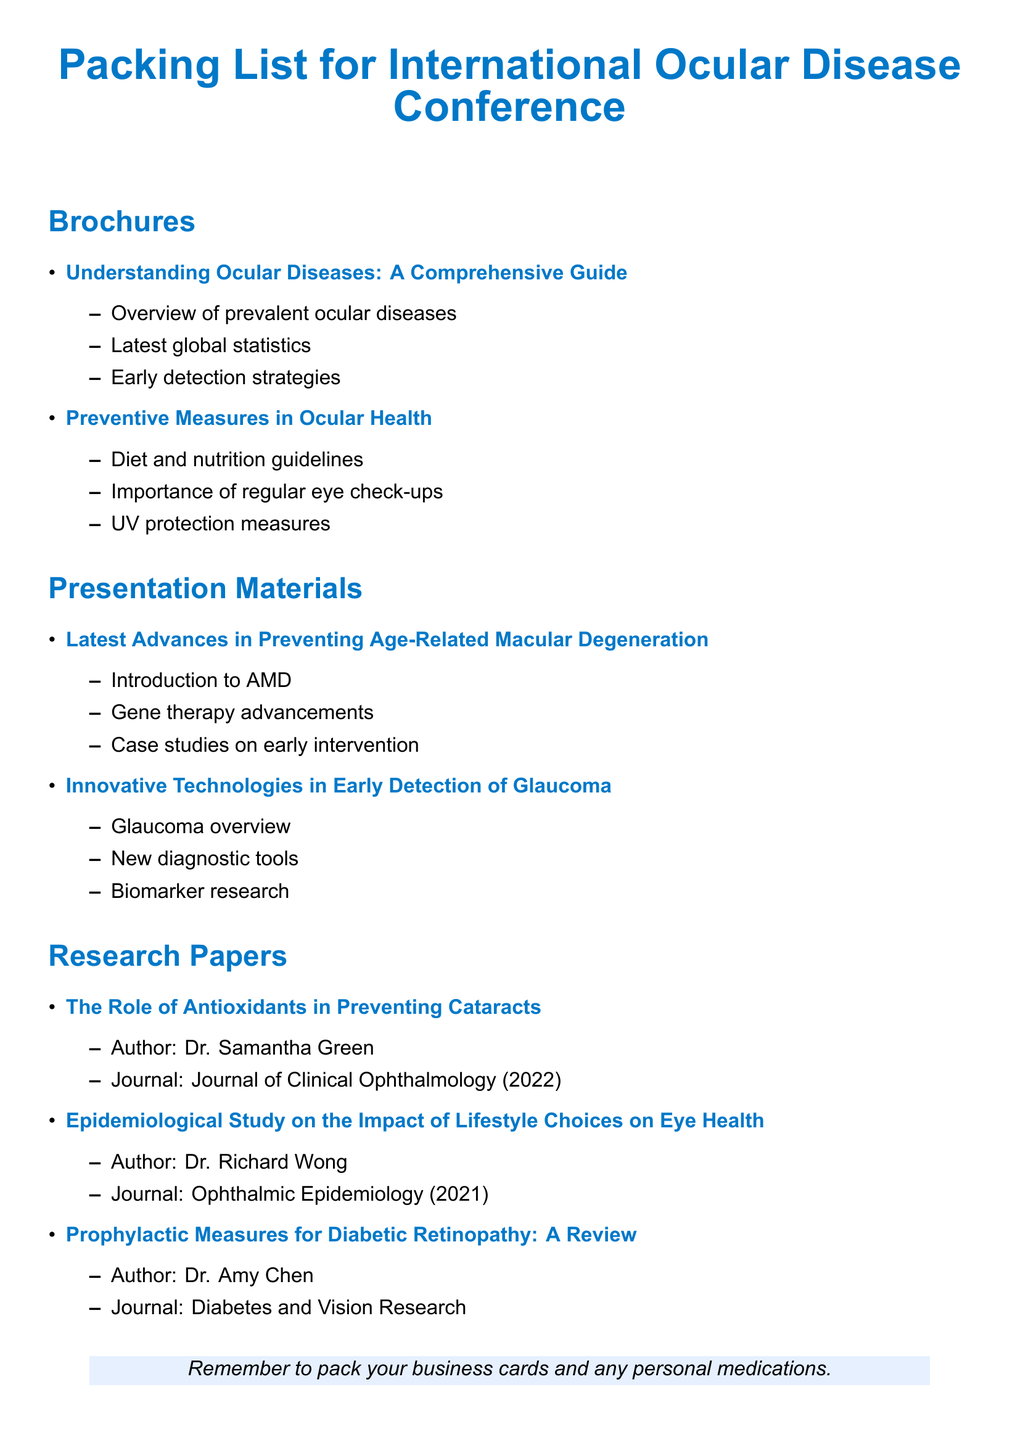What is the title of the brochure that discusses diet and nutrition? The title is listed in the Brochures section, specifically under the second item about preventive measures.
Answer: Preventive Measures in Ocular Health Who authored the research paper on preventing cataracts? The author is mentioned in the Research Papers section under the first item about antioxidants.
Answer: Dr. Samantha Green What year was the research paper by Dr. Richard Wong published? The publication year is specified in the Research Papers section alongside the title of the study.
Answer: 2021 What is one of the topics covered in the presentation materials? Topics are listed under the Presentation Materials section, and one can be derived from the first item mentioned.
Answer: Latest Advances in Preventing Age-Related Macular Degeneration What is the focus of the second presentation material? The focus is described in the Outline of the second item in Presentation Materials, outlining its key aspects.
Answer: Innovative Technologies in Early Detection of Glaucoma How many brochures are included in the packing list? The number can be counted from the Brochures section, which lists all individual brochures.
Answer: 2 What type of preventive measure is mentioned in the first brochure? The type can be inferred from the bullet points listed under the first brochure.
Answer: Early detection strategies What journal published the review by Dr. Amy Chen? This journal is found in the Research Papers section alongside the respective paper title.
Answer: Diabetes and Vision Research 